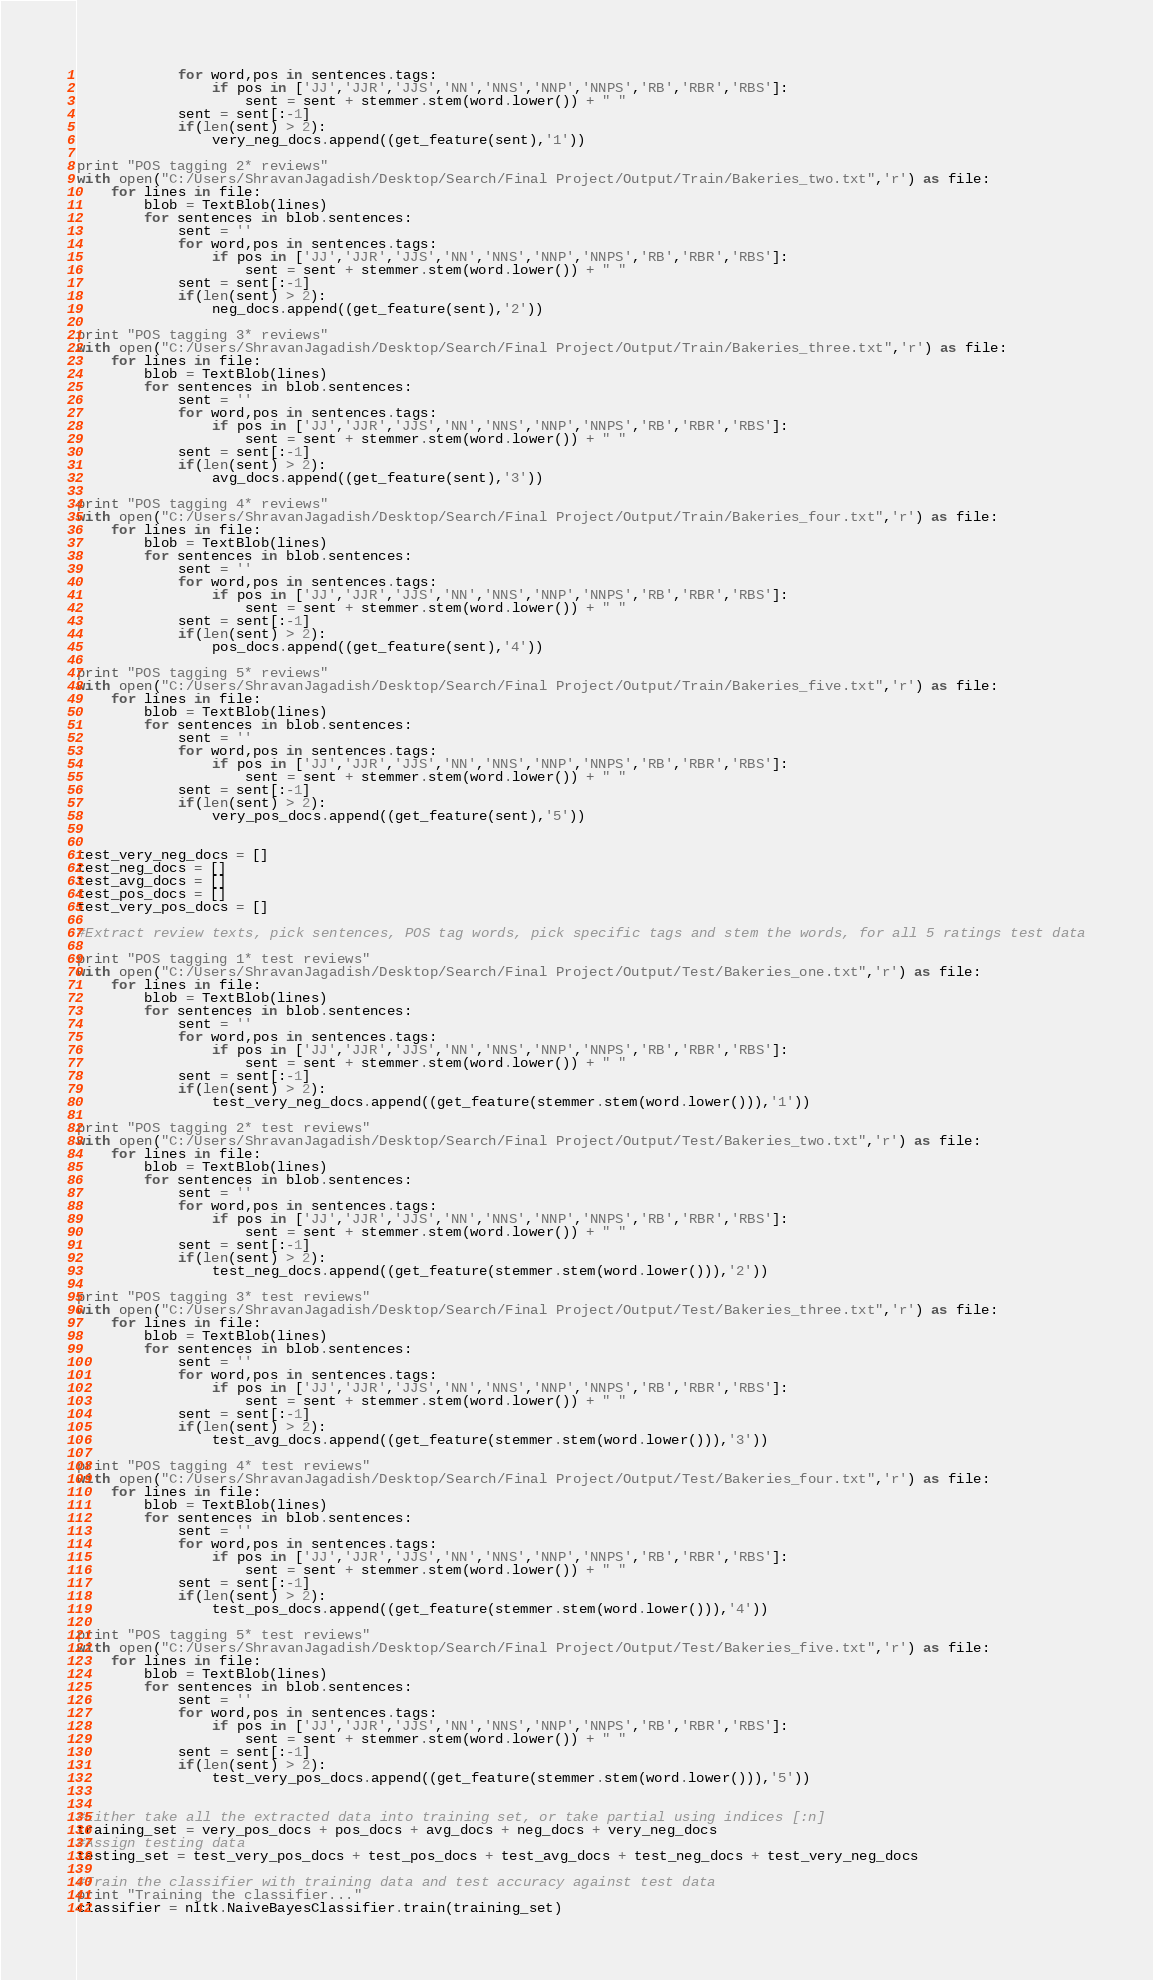Convert code to text. <code><loc_0><loc_0><loc_500><loc_500><_Python_>			for word,pos in sentences.tags:
				if pos in ['JJ','JJR','JJS','NN','NNS','NNP','NNPS','RB','RBR','RBS']:
					sent = sent + stemmer.stem(word.lower()) + " "
			sent = sent[:-1]
			if(len(sent) > 2):
				very_neg_docs.append((get_feature(sent),'1'))

print "POS tagging 2* reviews"					
with open("C:/Users/ShravanJagadish/Desktop/Search/Final Project/Output/Train/Bakeries_two.txt",'r') as file:    
    for lines in file:
        blob = TextBlob(lines)
        for sentences in blob.sentences:
			sent = ''
			for word,pos in sentences.tags:
				if pos in ['JJ','JJR','JJS','NN','NNS','NNP','NNPS','RB','RBR','RBS']:
					sent = sent + stemmer.stem(word.lower()) + " "
			sent = sent[:-1]
			if(len(sent) > 2):
				neg_docs.append((get_feature(sent),'2'))

print "POS tagging 3* reviews"					
with open("C:/Users/ShravanJagadish/Desktop/Search/Final Project/Output/Train/Bakeries_three.txt",'r') as file:    
    for lines in file:
        blob = TextBlob(lines)
        for sentences in blob.sentences:
			sent = ''
			for word,pos in sentences.tags:
				if pos in ['JJ','JJR','JJS','NN','NNS','NNP','NNPS','RB','RBR','RBS']:
					sent = sent + stemmer.stem(word.lower()) + " "
			sent = sent[:-1]
			if(len(sent) > 2):
				avg_docs.append((get_feature(sent),'3'))

print "POS tagging 4* reviews"					
with open("C:/Users/ShravanJagadish/Desktop/Search/Final Project/Output/Train/Bakeries_four.txt",'r') as file:    
	for lines in file:
		blob = TextBlob(lines)
		for sentences in blob.sentences:
			sent = ''
			for word,pos in sentences.tags:
				if pos in ['JJ','JJR','JJS','NN','NNS','NNP','NNPS','RB','RBR','RBS']:
					sent = sent + stemmer.stem(word.lower()) + " "
			sent = sent[:-1]
			if(len(sent) > 2):
				pos_docs.append((get_feature(sent),'4'))

print "POS tagging 5* reviews"					
with open("C:/Users/ShravanJagadish/Desktop/Search/Final Project/Output/Train/Bakeries_five.txt",'r') as file:    
    for lines in file:
        blob = TextBlob(lines)
        for sentences in blob.sentences:
			sent = ''
			for word,pos in sentences.tags:
				if pos in ['JJ','JJR','JJS','NN','NNS','NNP','NNPS','RB','RBR','RBS']:
					sent = sent + stemmer.stem(word.lower()) + " "
			sent = sent[:-1]
			if(len(sent) > 2):
				very_pos_docs.append((get_feature(sent),'5'))				
				
				
test_very_neg_docs = []
test_neg_docs = []
test_avg_docs = []
test_pos_docs = []
test_very_pos_docs = []

#Extract review texts, pick sentences, POS tag words, pick specific tags and stem the words, for all 5 ratings test data

print "POS tagging 1* test reviews"
with open("C:/Users/ShravanJagadish/Desktop/Search/Final Project/Output/Test/Bakeries_one.txt",'r') as file:    
    for lines in file:
        blob = TextBlob(lines)
        for sentences in blob.sentences:
			sent = ''
			for word,pos in sentences.tags:
				if pos in ['JJ','JJR','JJS','NN','NNS','NNP','NNPS','RB','RBR','RBS']:
					sent = sent + stemmer.stem(word.lower()) + " "
			sent = sent[:-1]
			if(len(sent) > 2):
				test_very_neg_docs.append((get_feature(stemmer.stem(word.lower())),'1'))

print "POS tagging 2* test reviews"					
with open("C:/Users/ShravanJagadish/Desktop/Search/Final Project/Output/Test/Bakeries_two.txt",'r') as file:    
    for lines in file:
        blob = TextBlob(lines)
        for sentences in blob.sentences:
			sent = ''
			for word,pos in sentences.tags:
				if pos in ['JJ','JJR','JJS','NN','NNS','NNP','NNPS','RB','RBR','RBS']:
					sent = sent + stemmer.stem(word.lower()) + " "
			sent = sent[:-1]
			if(len(sent) > 2):
				test_neg_docs.append((get_feature(stemmer.stem(word.lower())),'2'))

print "POS tagging 3* test reviews"					
with open("C:/Users/ShravanJagadish/Desktop/Search/Final Project/Output/Test/Bakeries_three.txt",'r') as file:    
    for lines in file:
        blob = TextBlob(lines)
        for sentences in blob.sentences:
			sent = ''
			for word,pos in sentences.tags:
				if pos in ['JJ','JJR','JJS','NN','NNS','NNP','NNPS','RB','RBR','RBS']:
					sent = sent + stemmer.stem(word.lower()) + " "
			sent = sent[:-1]
			if(len(sent) > 2):
				test_avg_docs.append((get_feature(stemmer.stem(word.lower())),'3'))				

print "POS tagging 4* test reviews"					
with open("C:/Users/ShravanJagadish/Desktop/Search/Final Project/Output/Test/Bakeries_four.txt",'r') as file:    
    for lines in file:
        blob = TextBlob(lines)
        for sentences in blob.sentences:
			sent = ''
			for word,pos in sentences.tags:
				if pos in ['JJ','JJR','JJS','NN','NNS','NNP','NNPS','RB','RBR','RBS']:
					sent = sent + stemmer.stem(word.lower()) + " "
			sent = sent[:-1]
			if(len(sent) > 2):
				test_pos_docs.append((get_feature(stemmer.stem(word.lower())),'4'))

print "POS tagging 5* test reviews"					
with open("C:/Users/ShravanJagadish/Desktop/Search/Final Project/Output/Test/Bakeries_five.txt",'r') as file:    
    for lines in file:
        blob = TextBlob(lines)
        for sentences in blob.sentences:
			sent = ''
			for word,pos in sentences.tags:
				if pos in ['JJ','JJR','JJS','NN','NNS','NNP','NNPS','RB','RBR','RBS']:
					sent = sent + stemmer.stem(word.lower()) + " "
			sent = sent[:-1]
			if(len(sent) > 2):
				test_very_pos_docs.append((get_feature(stemmer.stem(word.lower())),'5'))				


#Either take all the extracted data into training set, or take partial using indices [:n]				
training_set = very_pos_docs + pos_docs + avg_docs + neg_docs + very_neg_docs
#Assign testing data
testing_set = test_very_pos_docs + test_pos_docs + test_avg_docs + test_neg_docs + test_very_neg_docs

#Train the classifier with training data and test accuracy against test data
print "Training the classifier..."
classifier = nltk.NaiveBayesClassifier.train(training_set)</code> 